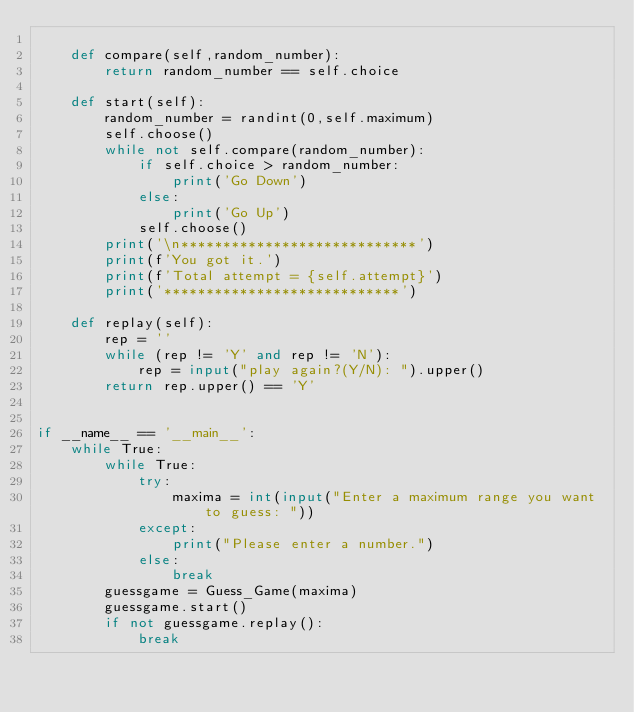<code> <loc_0><loc_0><loc_500><loc_500><_Python_>
    def compare(self,random_number):
        return random_number == self.choice

    def start(self):
        random_number = randint(0,self.maximum)
        self.choose()
        while not self.compare(random_number):
            if self.choice > random_number:
                print('Go Down')
            else:
                print('Go Up')
            self.choose()
        print('\n****************************')
        print(f'You got it.')
        print(f'Total attempt = {self.attempt}')  
        print('****************************')

    def replay(self):
        rep = ''
        while (rep != 'Y' and rep != 'N'):
            rep = input("play again?(Y/N): ").upper()
        return rep.upper() == 'Y' 


if __name__ == '__main__':        
    while True:
        while True: 
            try:
                maxima = int(input("Enter a maximum range you want to guess: "))
            except:
                print("Please enter a number.")
            else:
                break
        guessgame = Guess_Game(maxima)
        guessgame.start() 
        if not guessgame.replay():
            break
        </code> 